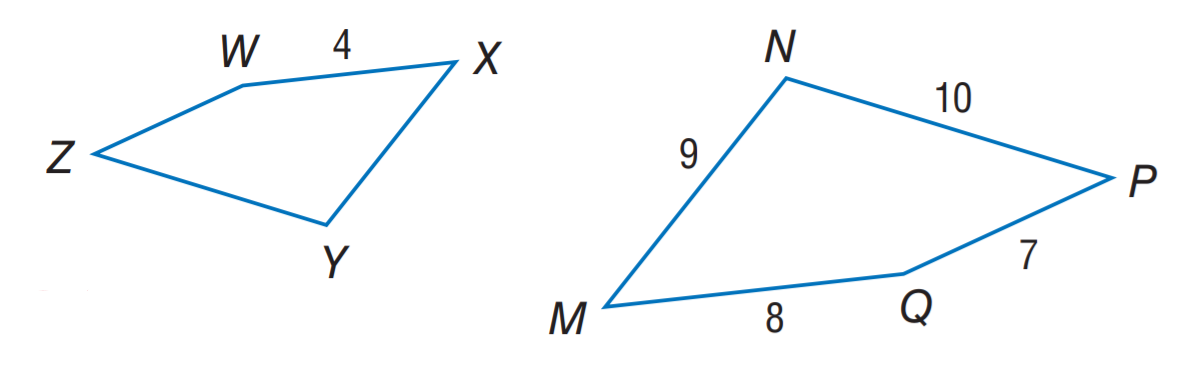Question: If M N P Q \sim X Y Z W, find the perimeter of M N P Q.
Choices:
A. 17
B. 18
C. 20
D. 34
Answer with the letter. Answer: D Question: If M N P Q \sim X Y Z W, find the perimeter of X Y Z W.
Choices:
A. 17
B. 18
C. 20
D. 34
Answer with the letter. Answer: A Question: If M N P Q \sim X Y Z W, find the scale factor of M N P Q to X Y Z W.
Choices:
A. 2
B. 3
C. 4
D. 7
Answer with the letter. Answer: A 